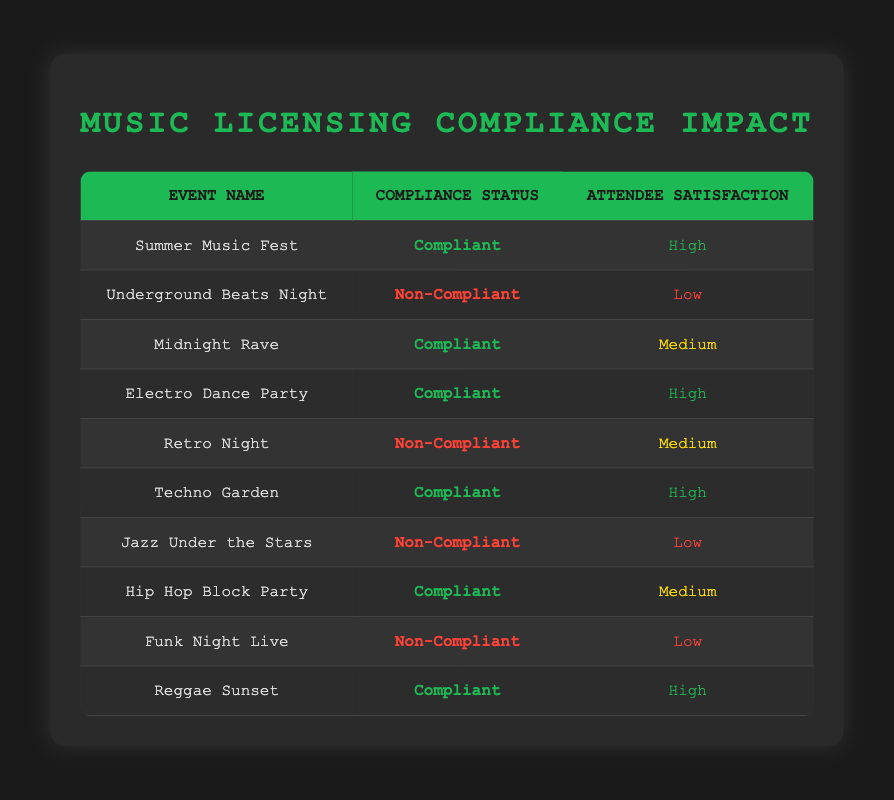What is the satisfaction rating for the "Techno Garden" event? The "Techno Garden" event is listed in the table under the compliant category with a satisfaction rating of "High." This can be found directly in the corresponding row for this event.
Answer: High How many events had a non-compliant status? By counting the rows with the "Non-Compliant" status in the compliance status column, we find that there are four such events: "Underground Beats Night," "Retro Night," "Jazz Under the Stars," and "Funk Night Live."
Answer: 4 What is the most common attendee satisfaction level among compliant events? To determine the most common satisfaction level, we look at the satisfaction ratings for compliant events: "High," "Medium," "High," "High," and "Medium." The "High" rating appears three times, while "Medium" appears twice. Thus, the most common rating is "High."
Answer: High Is there any event with high satisfaction that is non-compliant? The table shows that none of the events categorized as non-compliant have a "High" satisfaction rating; the ratings are only "Low" or "Medium" for the non-compliant events.
Answer: No If we sum the number of "High" satisfaction ratings, how many do we find? There are three events with a "High" satisfaction rating: "Summer Music Fest," "Electro Dance Party," and "Techno Garden." Adding them up gives a total of 3 "High" satisfaction events.
Answer: 3 What is the total number of compliant events categorized as having medium satisfaction? In the table, the only compliant event with a "Medium" satisfaction rating is the "Hip Hop Block Party." Therefore, the total number of compliant events with medium satisfaction is 1.
Answer: 1 Which type of music event has the highest number of attendees experiencing low satisfaction? There are three non-compliant events with low satisfaction ratings: "Underground Beats Night," "Jazz Under the Stars," and "Funk Night Live." Hence, the highest number of attendees experiencing low satisfaction is attributed to three events.
Answer: 3 How many compliant events had a "Medium" satisfaction rating? By reviewing the table, we find that the event "Midnight Rave" and "Hip Hop Block Party" are the only compliant events with a "Medium" satisfaction rating. This totals to two compliant events with medium satisfaction.
Answer: 2 If we consider events with satisfied ratings above medium, how many are compliant? The compliant events with a satisfaction rating above medium are "Summer Music Fest," "Electro Dance Party," "Techno Garden," and "Reggae Sunset." Thus, there are four compliant events with ratings above medium.
Answer: 4 